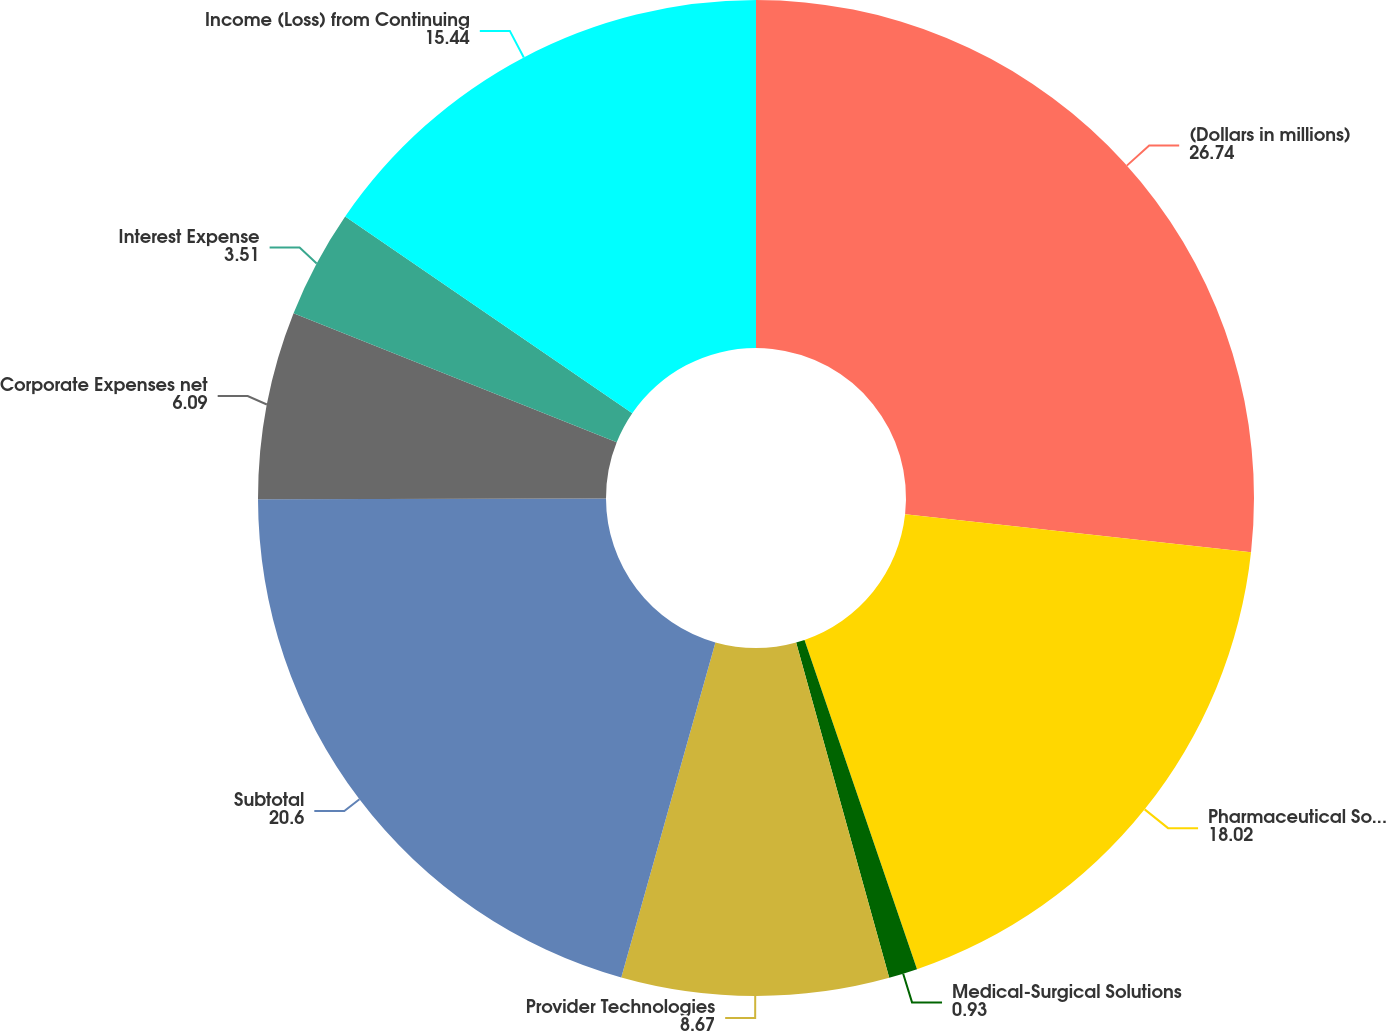<chart> <loc_0><loc_0><loc_500><loc_500><pie_chart><fcel>(Dollars in millions)<fcel>Pharmaceutical Solutions<fcel>Medical-Surgical Solutions<fcel>Provider Technologies<fcel>Subtotal<fcel>Corporate Expenses net<fcel>Interest Expense<fcel>Income (Loss) from Continuing<nl><fcel>26.74%<fcel>18.02%<fcel>0.93%<fcel>8.67%<fcel>20.6%<fcel>6.09%<fcel>3.51%<fcel>15.44%<nl></chart> 